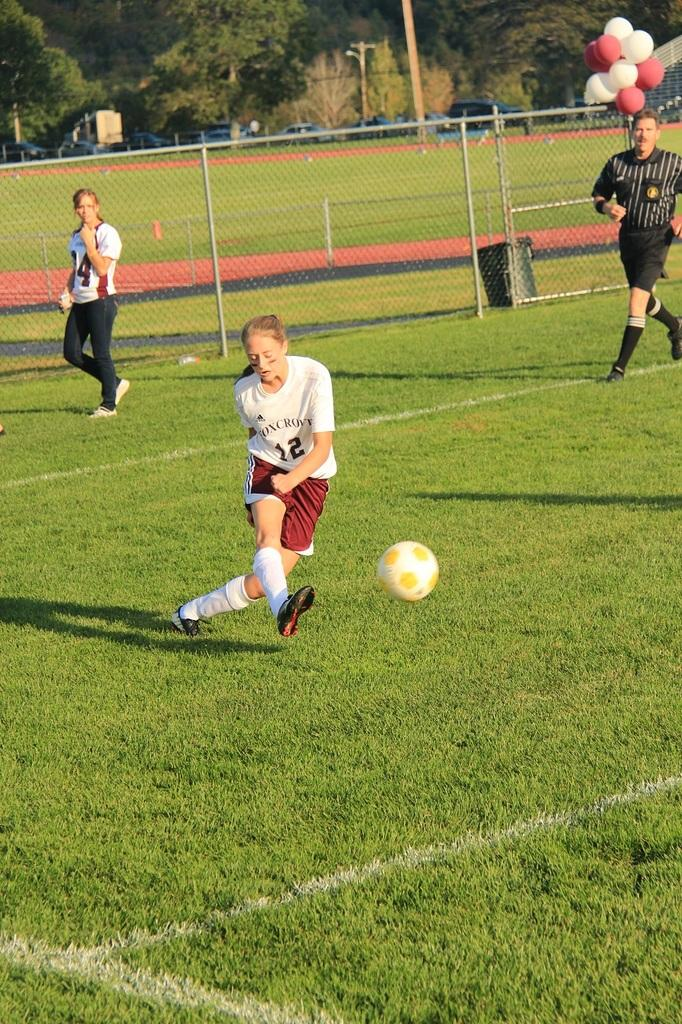<image>
Write a terse but informative summary of the picture. Soccer player wearing a shirt that says Oxcroft kicking a ball. 